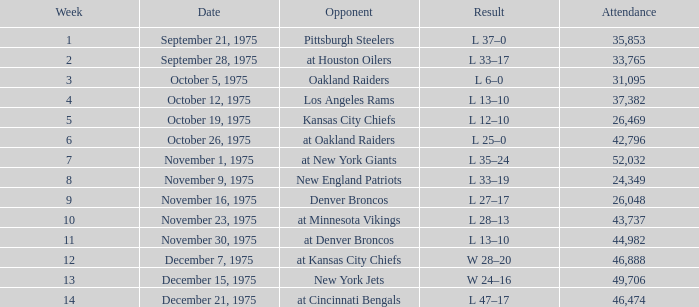What is the lowest Week when the result was l 13–10, November 30, 1975, with more than 44,982 people in attendance? None. 